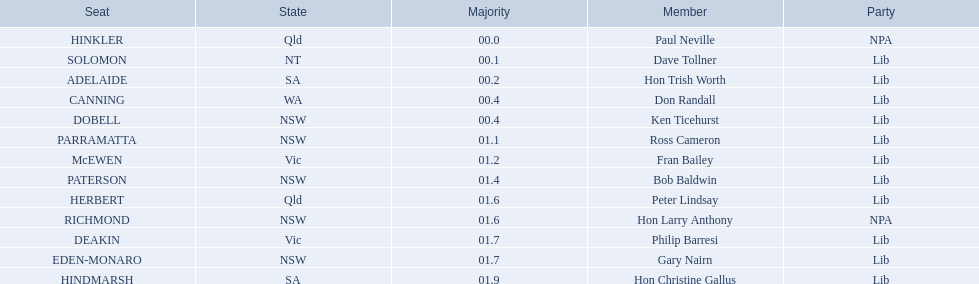Who are the members of the liberal party? Dave Tollner, Hon Trish Worth, Don Randall, Ken Ticehurst, Ross Cameron, Fran Bailey, Bob Baldwin, Peter Lindsay, Philip Barresi, Gary Nairn, Hon Christine Gallus. Which liberal party members are located in south australia? Hon Trish Worth, Hon Christine Gallus. What is the largest majority difference between members in south australia? 01.9. 